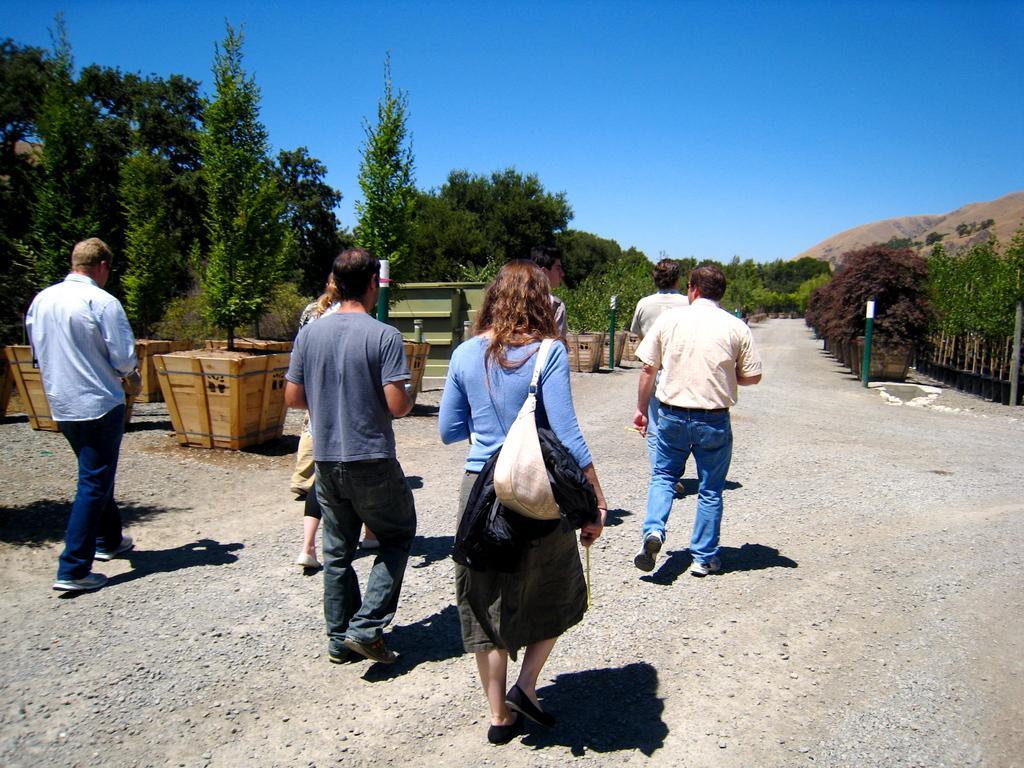How would you summarize this image in a sentence or two? There are persons in different color dresses, walking on the road. On the left side, there are pot plants arranged on the road. on the right side, there are pot plants arranged on the road. In the background, there are trees, there is a mountain and there is blue sky. 